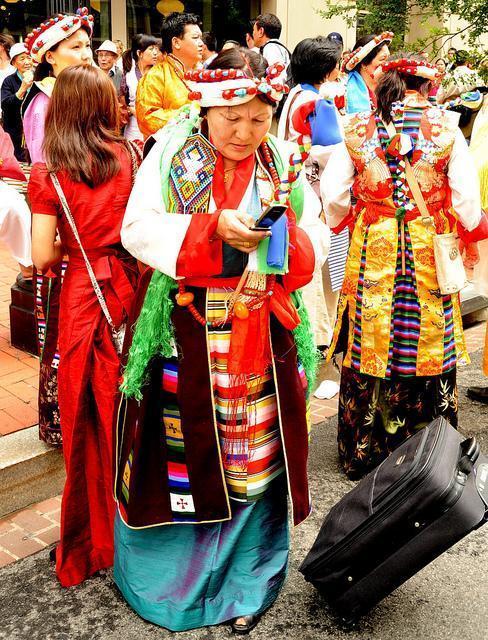How many people are there?
Give a very brief answer. 9. 